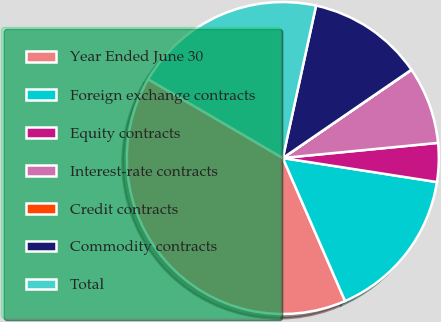Convert chart. <chart><loc_0><loc_0><loc_500><loc_500><pie_chart><fcel>Year Ended June 30<fcel>Foreign exchange contracts<fcel>Equity contracts<fcel>Interest-rate contracts<fcel>Credit contracts<fcel>Commodity contracts<fcel>Total<nl><fcel>39.96%<fcel>16.0%<fcel>4.01%<fcel>8.01%<fcel>0.02%<fcel>12.0%<fcel>19.99%<nl></chart> 